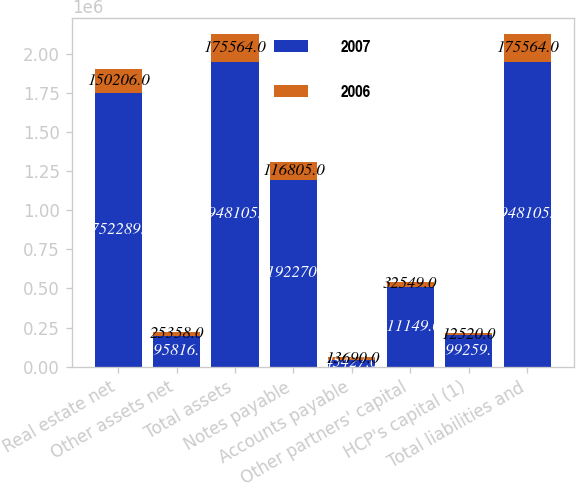<chart> <loc_0><loc_0><loc_500><loc_500><stacked_bar_chart><ecel><fcel>Real estate net<fcel>Other assets net<fcel>Total assets<fcel>Notes payable<fcel>Accounts payable<fcel>Other partners' capital<fcel>HCP's capital (1)<fcel>Total liabilities and<nl><fcel>2007<fcel>1.75229e+06<fcel>195816<fcel>1.9481e+06<fcel>1.19227e+06<fcel>45427<fcel>511149<fcel>199259<fcel>1.9481e+06<nl><fcel>2006<fcel>150206<fcel>25358<fcel>175564<fcel>116805<fcel>13690<fcel>32549<fcel>12520<fcel>175564<nl></chart> 